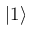<formula> <loc_0><loc_0><loc_500><loc_500>| 1 \rangle</formula> 